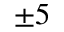Convert formula to latex. <formula><loc_0><loc_0><loc_500><loc_500>\pm 5</formula> 